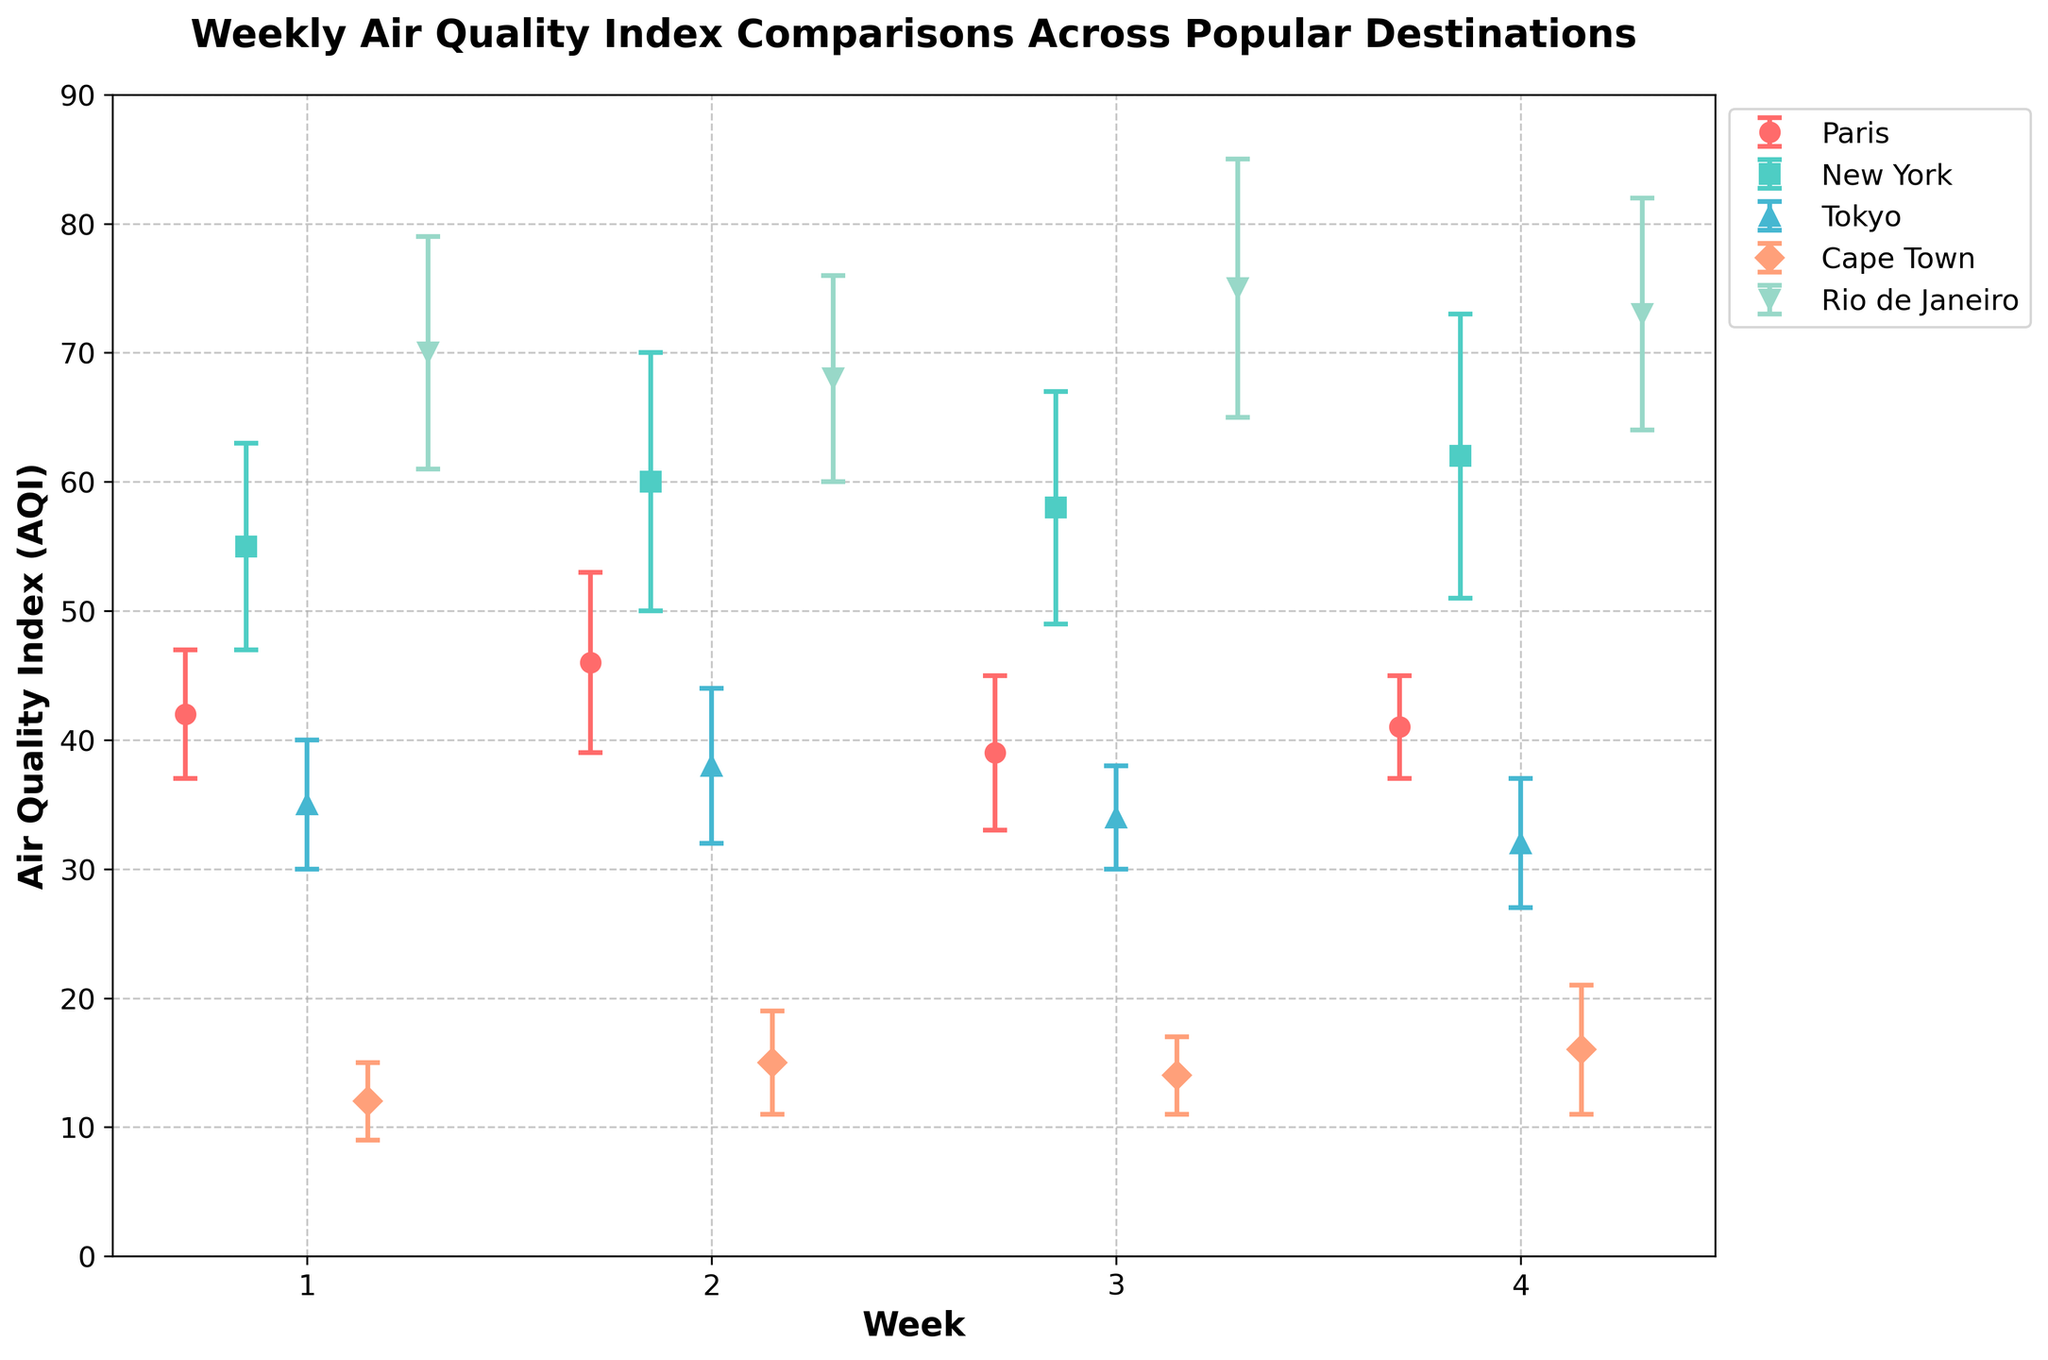What's the title of this figure? The title is found at the top of the figure in bold text. It reads, “Weekly Air Quality Index Comparisons Across Popular Destinations.”
Answer: Weekly Air Quality Index Comparisons Across Popular Destinations What is the Air Quality Index (AQI) for Tokyo in week 3? Locate Tokyo on the figure and find the data point corresponding to week 3. The AQI is represented by a marker and the value is visible.
Answer: 34 Which location has the highest AQI in week 4? Look at the markers representing week 4 for all locations and find the one with the highest AQI value. Rio de Janeiro has the highest AQI in week 4.
Answer: Rio de Janeiro What is the approximate range of AQI values in Cape Town over the 4 weeks? Examine all the AQI values for Cape Town across the 4 weeks and determine the minimum and maximum values to find the range.
Answer: 12 to 16 Does New York's AQI increase or decrease from week 1 to week 4? Compare the AQI values of New York from week 1 to week 4. Identify whether the values show an increasing or decreasing trend.
Answer: Increase Which destination has the lowest average AQI over the 4 weeks? To find the lowest average, sum the AQI values over the 4 weeks for each destination and divide by 4, then compare the averages. Cape Town has the lowest average AQI.
Answer: Cape Town Calculate the average AQI for Paris over the 4 weeks. Sum the AQI values for Paris from weeks 1 to 4 and divide by 4. (42 + 46 + 39 + 41) / 4 = 168 / 4 = 42
Answer: 42 In week 2, which location has the greatest variability in AQI, and how do you know? Look at the error bars for week 2 across all locations and determine which has the largest error bar. New York has the greatest variability with the largest error bar in week 2.
Answer: New York Between Tokyo and New York, which location has more stable AQI values over the 4 weeks? Compare the length of the error bars for Tokyo and New York across the 4 weeks. The shorter the error bars, the more stable the AQI values. Tokyo has more stable AQI values with shorter error bars.
Answer: Tokyo 